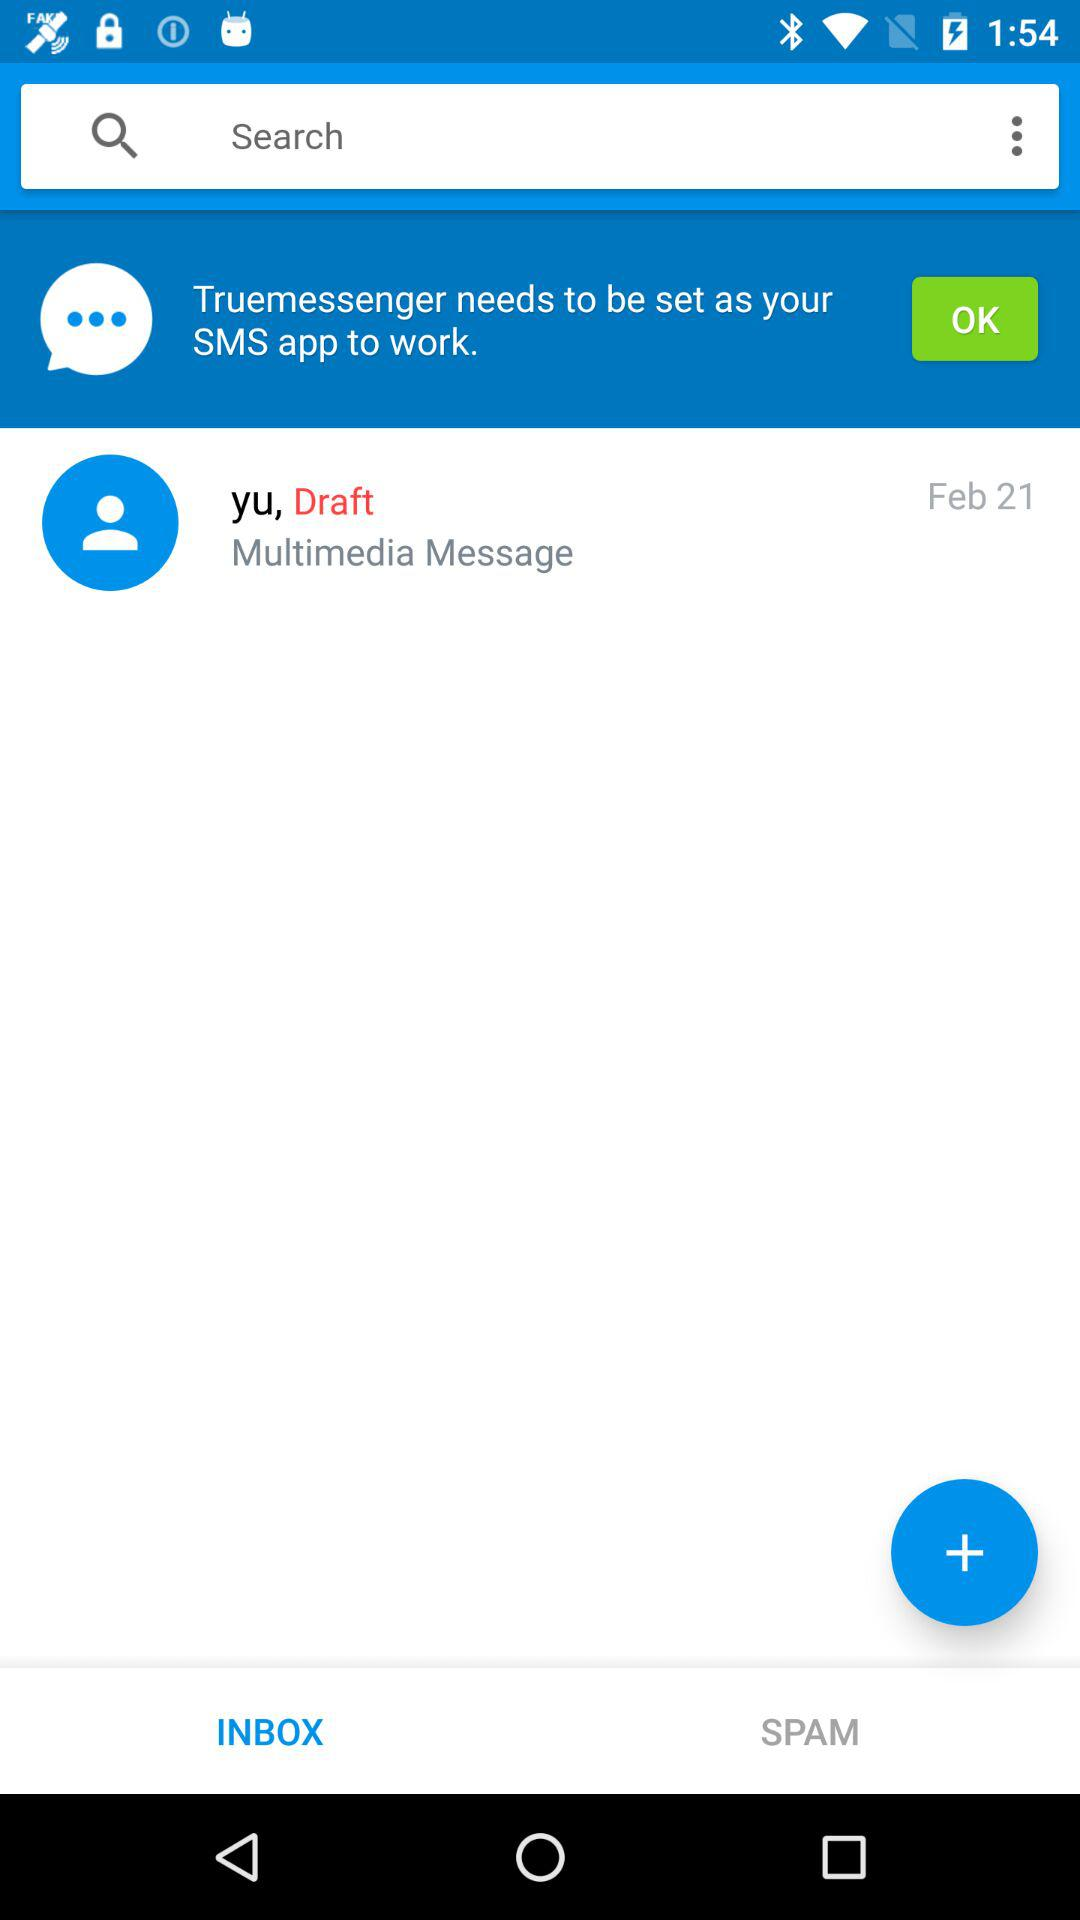What is the name of the application? The name of the application is "Truemessenger". 